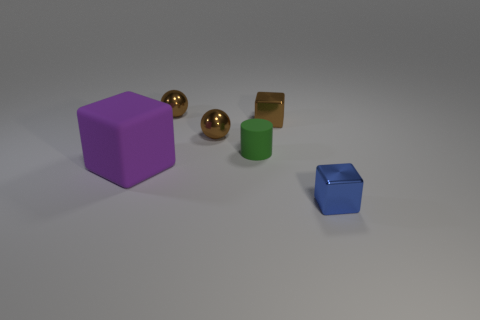If this were a physics experiment, what could be a possible hypothesis based on the objects' arrangement? If this setup were part of a physics experiment, one possible hypothesis could be to examine the differences in rolling or sliding friction among objects with varying surface materials and shapes when placed on the same inclined surface. It would be interesting to observe how each object's motion is affected, especially comparing the spheres and blocks. 